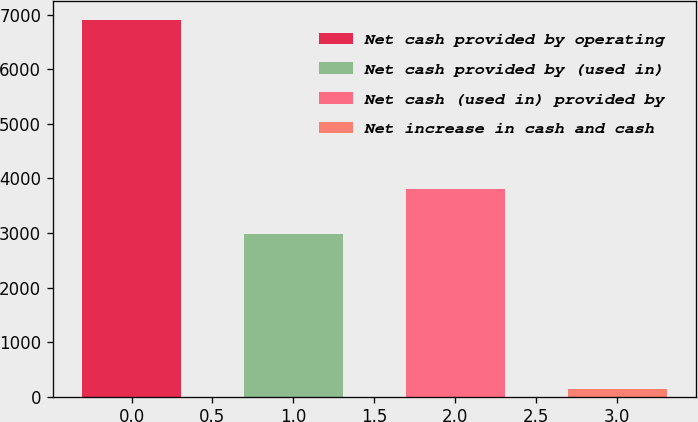<chart> <loc_0><loc_0><loc_500><loc_500><bar_chart><fcel>Net cash provided by operating<fcel>Net cash provided by (used in)<fcel>Net cash (used in) provided by<fcel>Net increase in cash and cash<nl><fcel>6911<fcel>2974<fcel>3800<fcel>137<nl></chart> 